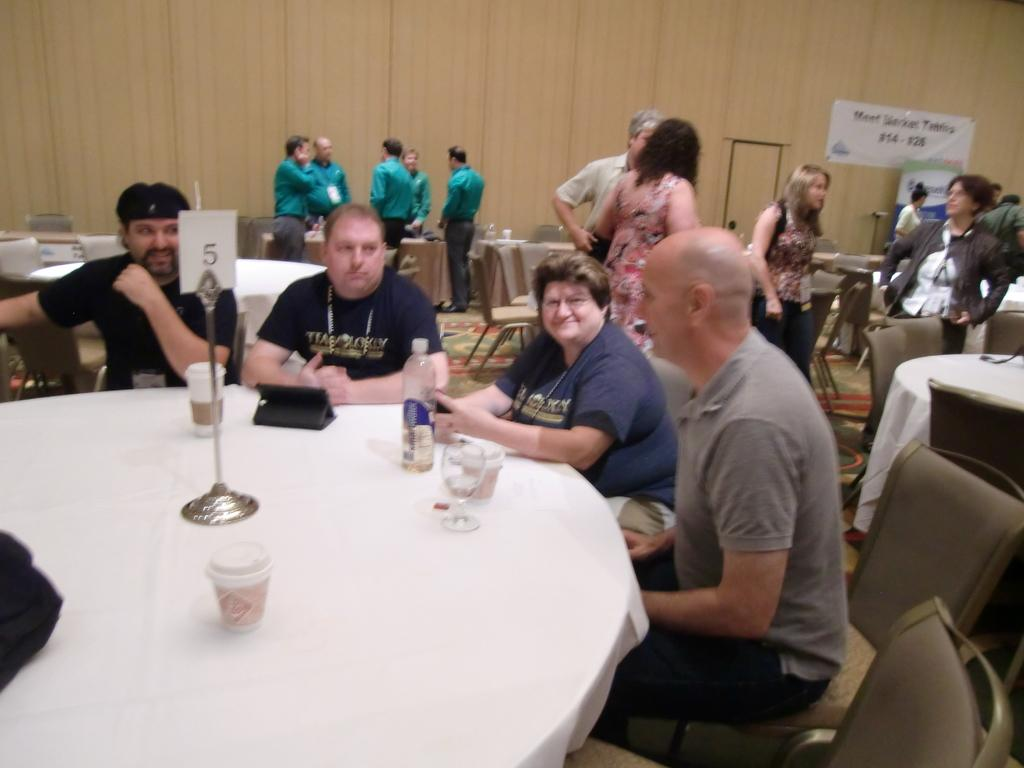What are the people in the image doing? The people in the image are sitting around a table. What objects can be seen on the table? There are cups and glasses on the table. Are there any people standing in the image? Yes, there are people standing beside the table. What type of leather is used to make the bag in the image? There is no bag present in the image, so it is not possible to determine the type of leather used. 